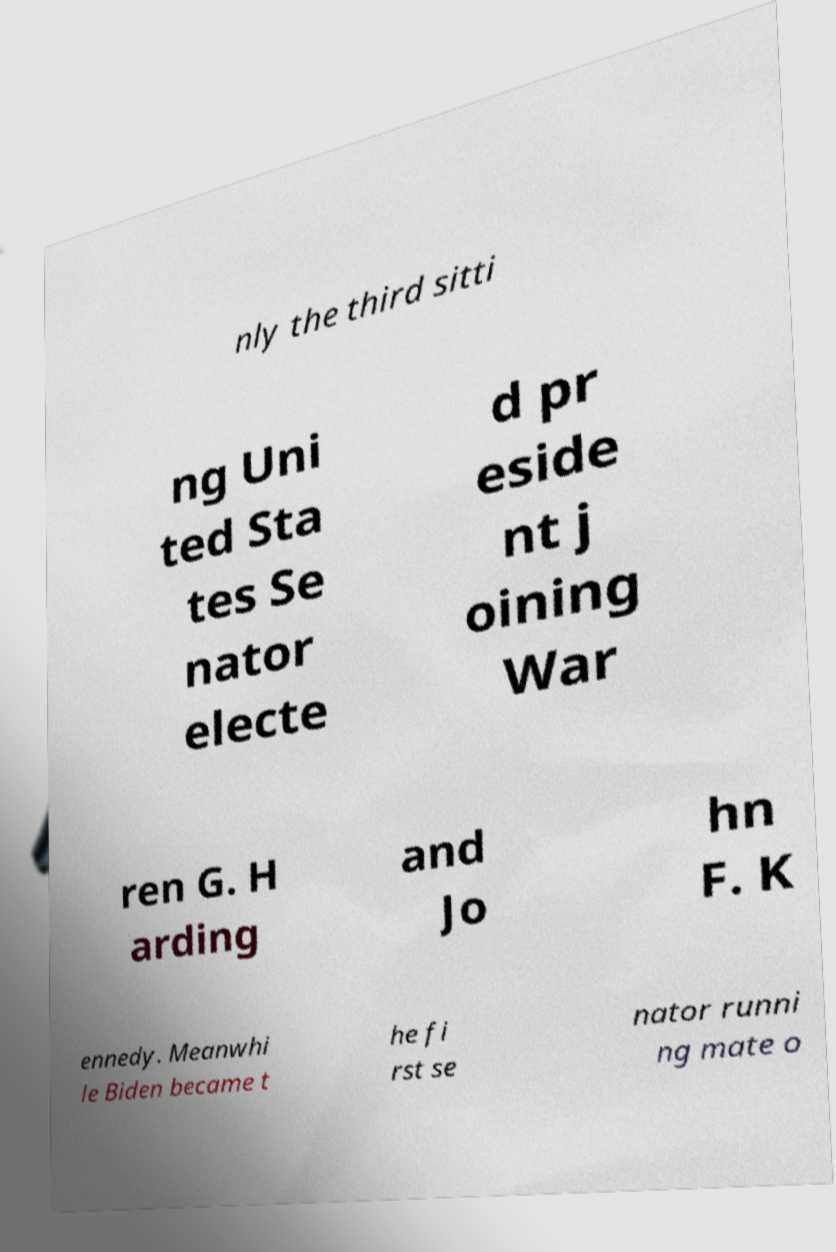Please identify and transcribe the text found in this image. nly the third sitti ng Uni ted Sta tes Se nator electe d pr eside nt j oining War ren G. H arding and Jo hn F. K ennedy. Meanwhi le Biden became t he fi rst se nator runni ng mate o 